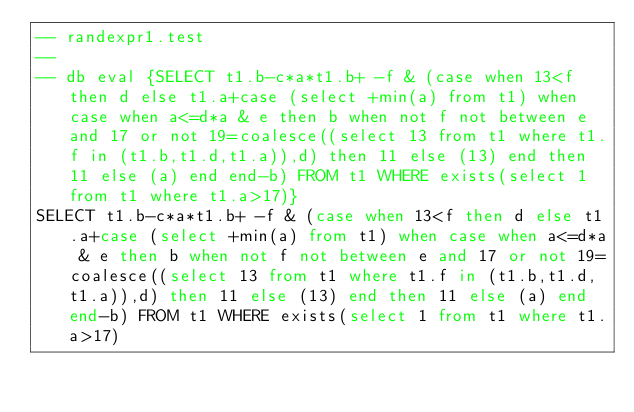<code> <loc_0><loc_0><loc_500><loc_500><_SQL_>-- randexpr1.test
-- 
-- db eval {SELECT t1.b-c*a*t1.b+ -f & (case when 13<f then d else t1.a+case (select +min(a) from t1) when case when a<=d*a & e then b when not f not between e and 17 or not 19=coalesce((select 13 from t1 where t1.f in (t1.b,t1.d,t1.a)),d) then 11 else (13) end then 11 else (a) end end-b) FROM t1 WHERE exists(select 1 from t1 where t1.a>17)}
SELECT t1.b-c*a*t1.b+ -f & (case when 13<f then d else t1.a+case (select +min(a) from t1) when case when a<=d*a & e then b when not f not between e and 17 or not 19=coalesce((select 13 from t1 where t1.f in (t1.b,t1.d,t1.a)),d) then 11 else (13) end then 11 else (a) end end-b) FROM t1 WHERE exists(select 1 from t1 where t1.a>17)</code> 